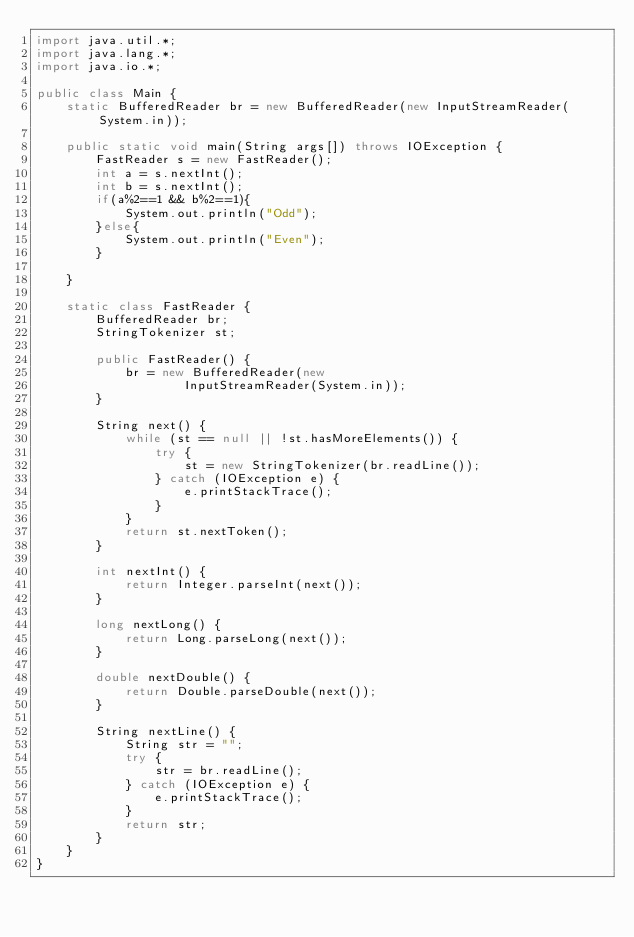Convert code to text. <code><loc_0><loc_0><loc_500><loc_500><_Java_>import java.util.*;
import java.lang.*;
import java.io.*;

public class Main {
    static BufferedReader br = new BufferedReader(new InputStreamReader(System.in));

    public static void main(String args[]) throws IOException {
        FastReader s = new FastReader();
        int a = s.nextInt();
        int b = s.nextInt();
        if(a%2==1 && b%2==1){
            System.out.println("Odd");
        }else{
            System.out.println("Even");
        }

    }

    static class FastReader {
        BufferedReader br;
        StringTokenizer st;

        public FastReader() {
            br = new BufferedReader(new
                    InputStreamReader(System.in));
        }

        String next() {
            while (st == null || !st.hasMoreElements()) {
                try {
                    st = new StringTokenizer(br.readLine());
                } catch (IOException e) {
                    e.printStackTrace();
                }
            }
            return st.nextToken();
        }

        int nextInt() {
            return Integer.parseInt(next());
        }

        long nextLong() {
            return Long.parseLong(next());
        }

        double nextDouble() {
            return Double.parseDouble(next());
        }

        String nextLine() {
            String str = "";
            try {
                str = br.readLine();
            } catch (IOException e) {
                e.printStackTrace();
            }
            return str;
        }
    }
}
</code> 